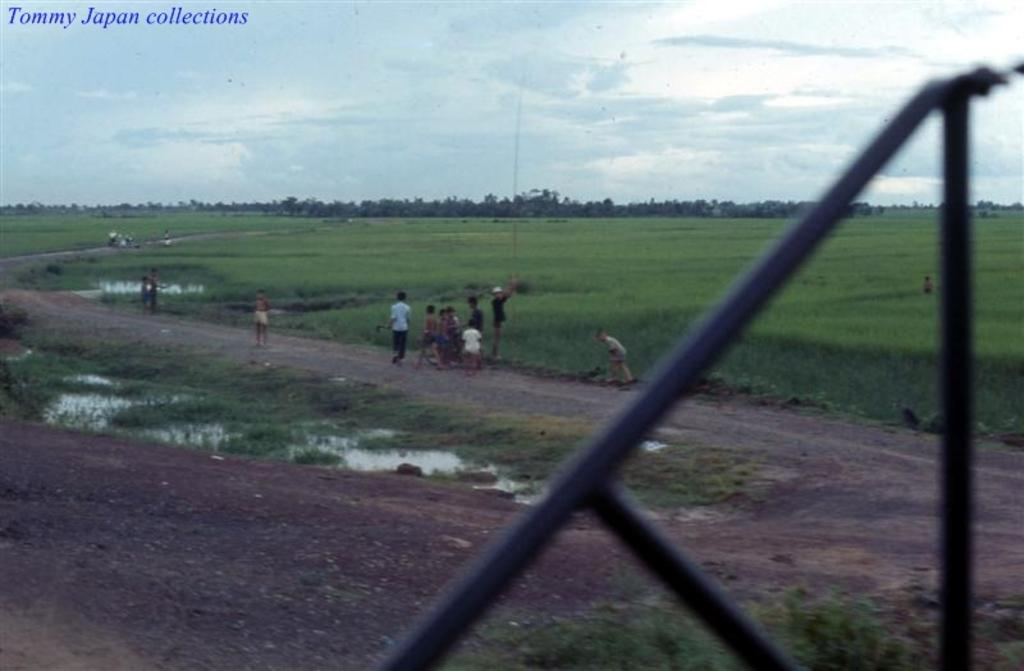What is the main subject in the center of the image? There are kids in the center of the image. What can be seen in the background of the image? There are fields and trees in the background of the image. What is visible at the top of the image? The sky is visible at the top of the image. What is present at the bottom of the image? There is a fence and water at the bottom of the image. What type of tooth is visible in the image? There is no tooth present in the image. How many nuts are being held by the kids in the image? There is no mention of nuts in the image; the kids are not holding any nuts. 